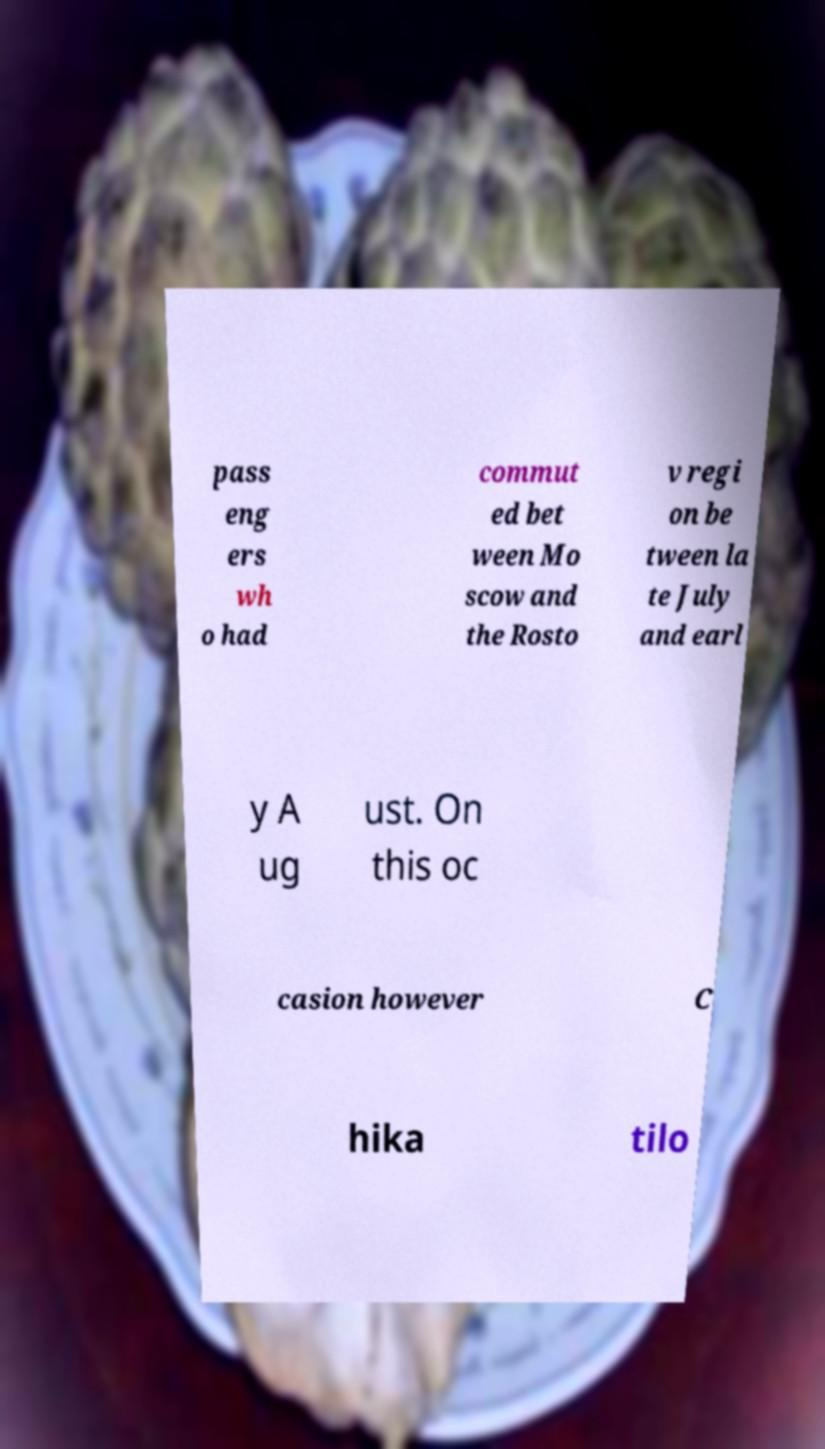Please read and relay the text visible in this image. What does it say? pass eng ers wh o had commut ed bet ween Mo scow and the Rosto v regi on be tween la te July and earl y A ug ust. On this oc casion however C hika tilo 